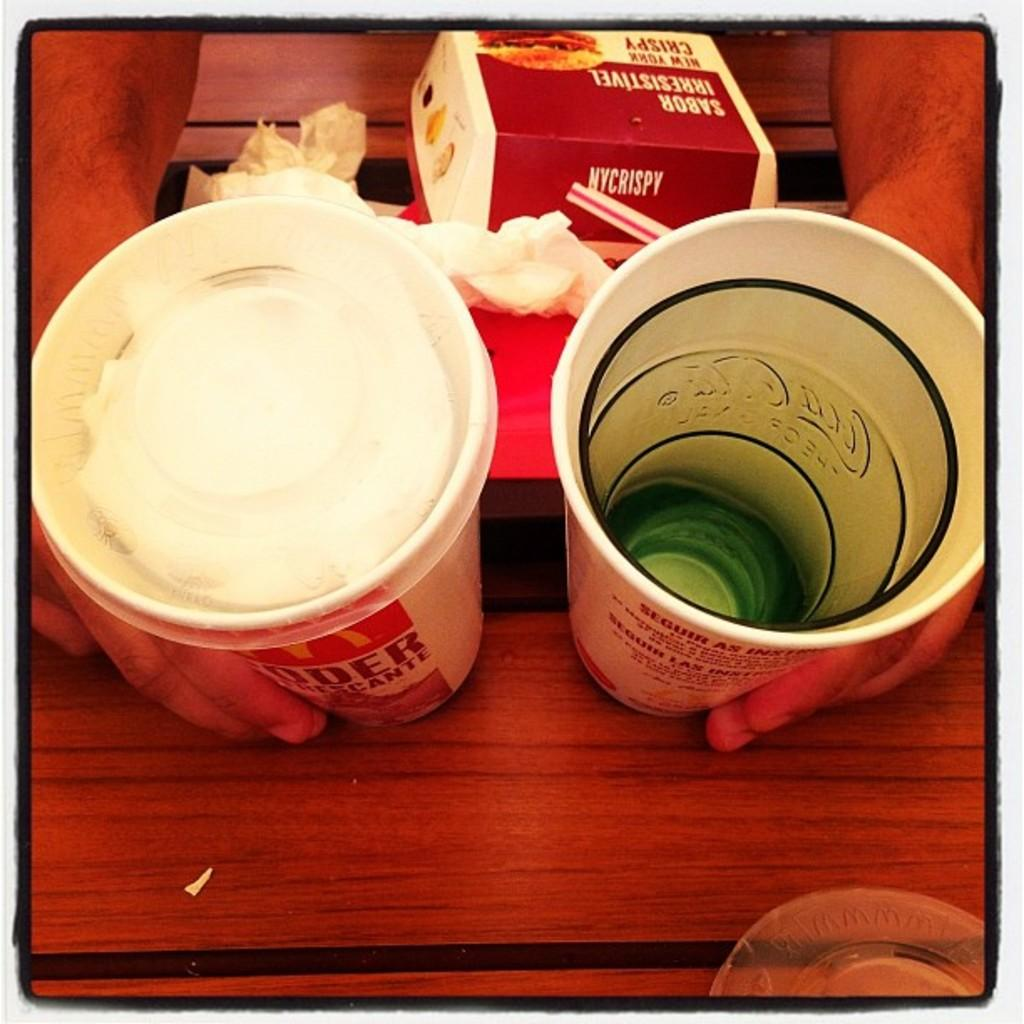What type of objects can be seen in the image? There are cups in the image. What else is present on the table in the image? There is a box on the table in the image. Who or what is holding the cups in the image? Human hands are holding cups in the image. What might be used for cleaning or wiping in the image? There is a napkin in the image for cleaning or wiping. Where are the objects located in the image? The objects are on a table in the image. What type of gold object can be seen in the image? There is no gold object present in the image. Can you tell me how many verses are written on the cups in the image? There are no verses written on the cups in the image. 